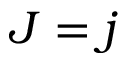<formula> <loc_0><loc_0><loc_500><loc_500>J = j</formula> 